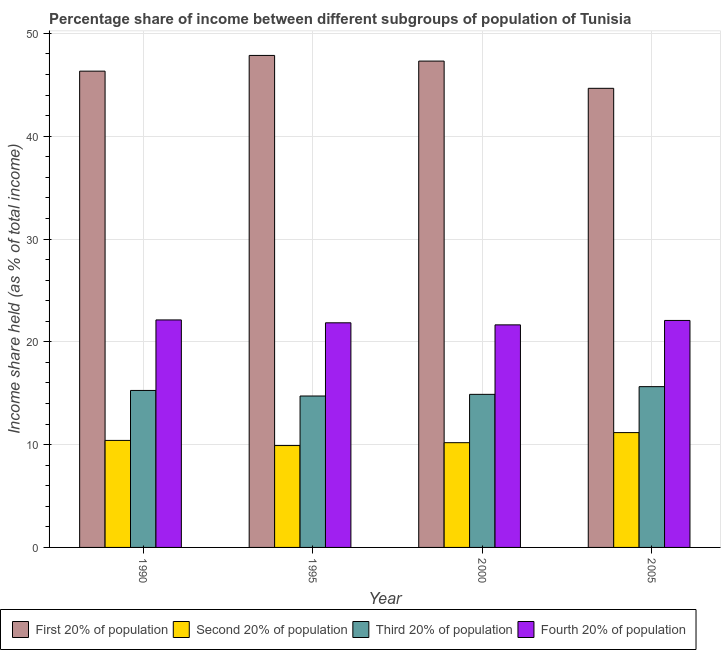How many groups of bars are there?
Offer a terse response. 4. Are the number of bars per tick equal to the number of legend labels?
Ensure brevity in your answer.  Yes. Are the number of bars on each tick of the X-axis equal?
Provide a succinct answer. Yes. What is the label of the 3rd group of bars from the left?
Your answer should be very brief. 2000. What is the share of the income held by fourth 20% of the population in 1990?
Ensure brevity in your answer.  22.13. Across all years, what is the maximum share of the income held by first 20% of the population?
Provide a short and direct response. 47.86. Across all years, what is the minimum share of the income held by third 20% of the population?
Provide a succinct answer. 14.73. What is the total share of the income held by fourth 20% of the population in the graph?
Keep it short and to the point. 87.71. What is the difference between the share of the income held by third 20% of the population in 1995 and that in 2005?
Give a very brief answer. -0.91. What is the difference between the share of the income held by first 20% of the population in 1995 and the share of the income held by second 20% of the population in 1990?
Your response must be concise. 1.53. What is the average share of the income held by third 20% of the population per year?
Make the answer very short. 15.13. In the year 1990, what is the difference between the share of the income held by second 20% of the population and share of the income held by first 20% of the population?
Your answer should be very brief. 0. What is the ratio of the share of the income held by second 20% of the population in 1990 to that in 2005?
Offer a terse response. 0.93. Is the difference between the share of the income held by fourth 20% of the population in 1990 and 1995 greater than the difference between the share of the income held by third 20% of the population in 1990 and 1995?
Ensure brevity in your answer.  No. What is the difference between the highest and the second highest share of the income held by fourth 20% of the population?
Make the answer very short. 0.05. What is the difference between the highest and the lowest share of the income held by second 20% of the population?
Offer a terse response. 1.26. Is it the case that in every year, the sum of the share of the income held by fourth 20% of the population and share of the income held by first 20% of the population is greater than the sum of share of the income held by third 20% of the population and share of the income held by second 20% of the population?
Give a very brief answer. No. What does the 4th bar from the left in 2000 represents?
Provide a short and direct response. Fourth 20% of population. What does the 4th bar from the right in 1995 represents?
Offer a terse response. First 20% of population. Is it the case that in every year, the sum of the share of the income held by first 20% of the population and share of the income held by second 20% of the population is greater than the share of the income held by third 20% of the population?
Give a very brief answer. Yes. How many bars are there?
Make the answer very short. 16. Are all the bars in the graph horizontal?
Provide a short and direct response. No. How many years are there in the graph?
Your response must be concise. 4. What is the difference between two consecutive major ticks on the Y-axis?
Your response must be concise. 10. How are the legend labels stacked?
Your answer should be very brief. Horizontal. What is the title of the graph?
Offer a very short reply. Percentage share of income between different subgroups of population of Tunisia. What is the label or title of the Y-axis?
Your answer should be compact. Income share held (as % of total income). What is the Income share held (as % of total income) of First 20% of population in 1990?
Offer a very short reply. 46.33. What is the Income share held (as % of total income) of Second 20% of population in 1990?
Provide a succinct answer. 10.41. What is the Income share held (as % of total income) in Third 20% of population in 1990?
Provide a succinct answer. 15.27. What is the Income share held (as % of total income) of Fourth 20% of population in 1990?
Your answer should be very brief. 22.13. What is the Income share held (as % of total income) of First 20% of population in 1995?
Offer a terse response. 47.86. What is the Income share held (as % of total income) of Second 20% of population in 1995?
Your answer should be very brief. 9.91. What is the Income share held (as % of total income) in Third 20% of population in 1995?
Provide a short and direct response. 14.73. What is the Income share held (as % of total income) of Fourth 20% of population in 1995?
Provide a succinct answer. 21.85. What is the Income share held (as % of total income) of First 20% of population in 2000?
Provide a short and direct response. 47.31. What is the Income share held (as % of total income) in Second 20% of population in 2000?
Your answer should be very brief. 10.19. What is the Income share held (as % of total income) of Third 20% of population in 2000?
Provide a succinct answer. 14.89. What is the Income share held (as % of total income) of Fourth 20% of population in 2000?
Provide a short and direct response. 21.65. What is the Income share held (as % of total income) of First 20% of population in 2005?
Provide a succinct answer. 44.66. What is the Income share held (as % of total income) in Second 20% of population in 2005?
Give a very brief answer. 11.17. What is the Income share held (as % of total income) of Third 20% of population in 2005?
Provide a succinct answer. 15.64. What is the Income share held (as % of total income) of Fourth 20% of population in 2005?
Offer a very short reply. 22.08. Across all years, what is the maximum Income share held (as % of total income) of First 20% of population?
Keep it short and to the point. 47.86. Across all years, what is the maximum Income share held (as % of total income) of Second 20% of population?
Your response must be concise. 11.17. Across all years, what is the maximum Income share held (as % of total income) of Third 20% of population?
Provide a short and direct response. 15.64. Across all years, what is the maximum Income share held (as % of total income) in Fourth 20% of population?
Your response must be concise. 22.13. Across all years, what is the minimum Income share held (as % of total income) in First 20% of population?
Provide a short and direct response. 44.66. Across all years, what is the minimum Income share held (as % of total income) in Second 20% of population?
Ensure brevity in your answer.  9.91. Across all years, what is the minimum Income share held (as % of total income) in Third 20% of population?
Provide a succinct answer. 14.73. Across all years, what is the minimum Income share held (as % of total income) in Fourth 20% of population?
Your response must be concise. 21.65. What is the total Income share held (as % of total income) in First 20% of population in the graph?
Keep it short and to the point. 186.16. What is the total Income share held (as % of total income) in Second 20% of population in the graph?
Provide a short and direct response. 41.68. What is the total Income share held (as % of total income) of Third 20% of population in the graph?
Give a very brief answer. 60.53. What is the total Income share held (as % of total income) in Fourth 20% of population in the graph?
Your response must be concise. 87.71. What is the difference between the Income share held (as % of total income) in First 20% of population in 1990 and that in 1995?
Your response must be concise. -1.53. What is the difference between the Income share held (as % of total income) of Third 20% of population in 1990 and that in 1995?
Offer a terse response. 0.54. What is the difference between the Income share held (as % of total income) in Fourth 20% of population in 1990 and that in 1995?
Your response must be concise. 0.28. What is the difference between the Income share held (as % of total income) of First 20% of population in 1990 and that in 2000?
Offer a terse response. -0.98. What is the difference between the Income share held (as % of total income) in Second 20% of population in 1990 and that in 2000?
Offer a very short reply. 0.22. What is the difference between the Income share held (as % of total income) in Third 20% of population in 1990 and that in 2000?
Keep it short and to the point. 0.38. What is the difference between the Income share held (as % of total income) in Fourth 20% of population in 1990 and that in 2000?
Your answer should be very brief. 0.48. What is the difference between the Income share held (as % of total income) in First 20% of population in 1990 and that in 2005?
Give a very brief answer. 1.67. What is the difference between the Income share held (as % of total income) of Second 20% of population in 1990 and that in 2005?
Provide a succinct answer. -0.76. What is the difference between the Income share held (as % of total income) in Third 20% of population in 1990 and that in 2005?
Give a very brief answer. -0.37. What is the difference between the Income share held (as % of total income) of First 20% of population in 1995 and that in 2000?
Provide a succinct answer. 0.55. What is the difference between the Income share held (as % of total income) in Second 20% of population in 1995 and that in 2000?
Give a very brief answer. -0.28. What is the difference between the Income share held (as % of total income) in Third 20% of population in 1995 and that in 2000?
Provide a succinct answer. -0.16. What is the difference between the Income share held (as % of total income) of Fourth 20% of population in 1995 and that in 2000?
Provide a short and direct response. 0.2. What is the difference between the Income share held (as % of total income) of First 20% of population in 1995 and that in 2005?
Offer a very short reply. 3.2. What is the difference between the Income share held (as % of total income) in Second 20% of population in 1995 and that in 2005?
Give a very brief answer. -1.26. What is the difference between the Income share held (as % of total income) in Third 20% of population in 1995 and that in 2005?
Ensure brevity in your answer.  -0.91. What is the difference between the Income share held (as % of total income) in Fourth 20% of population in 1995 and that in 2005?
Give a very brief answer. -0.23. What is the difference between the Income share held (as % of total income) in First 20% of population in 2000 and that in 2005?
Your answer should be compact. 2.65. What is the difference between the Income share held (as % of total income) of Second 20% of population in 2000 and that in 2005?
Provide a short and direct response. -0.98. What is the difference between the Income share held (as % of total income) of Third 20% of population in 2000 and that in 2005?
Give a very brief answer. -0.75. What is the difference between the Income share held (as % of total income) in Fourth 20% of population in 2000 and that in 2005?
Offer a terse response. -0.43. What is the difference between the Income share held (as % of total income) of First 20% of population in 1990 and the Income share held (as % of total income) of Second 20% of population in 1995?
Provide a short and direct response. 36.42. What is the difference between the Income share held (as % of total income) of First 20% of population in 1990 and the Income share held (as % of total income) of Third 20% of population in 1995?
Give a very brief answer. 31.6. What is the difference between the Income share held (as % of total income) in First 20% of population in 1990 and the Income share held (as % of total income) in Fourth 20% of population in 1995?
Offer a very short reply. 24.48. What is the difference between the Income share held (as % of total income) of Second 20% of population in 1990 and the Income share held (as % of total income) of Third 20% of population in 1995?
Make the answer very short. -4.32. What is the difference between the Income share held (as % of total income) in Second 20% of population in 1990 and the Income share held (as % of total income) in Fourth 20% of population in 1995?
Keep it short and to the point. -11.44. What is the difference between the Income share held (as % of total income) of Third 20% of population in 1990 and the Income share held (as % of total income) of Fourth 20% of population in 1995?
Offer a very short reply. -6.58. What is the difference between the Income share held (as % of total income) of First 20% of population in 1990 and the Income share held (as % of total income) of Second 20% of population in 2000?
Keep it short and to the point. 36.14. What is the difference between the Income share held (as % of total income) of First 20% of population in 1990 and the Income share held (as % of total income) of Third 20% of population in 2000?
Ensure brevity in your answer.  31.44. What is the difference between the Income share held (as % of total income) in First 20% of population in 1990 and the Income share held (as % of total income) in Fourth 20% of population in 2000?
Your answer should be very brief. 24.68. What is the difference between the Income share held (as % of total income) of Second 20% of population in 1990 and the Income share held (as % of total income) of Third 20% of population in 2000?
Offer a terse response. -4.48. What is the difference between the Income share held (as % of total income) of Second 20% of population in 1990 and the Income share held (as % of total income) of Fourth 20% of population in 2000?
Keep it short and to the point. -11.24. What is the difference between the Income share held (as % of total income) of Third 20% of population in 1990 and the Income share held (as % of total income) of Fourth 20% of population in 2000?
Give a very brief answer. -6.38. What is the difference between the Income share held (as % of total income) in First 20% of population in 1990 and the Income share held (as % of total income) in Second 20% of population in 2005?
Offer a very short reply. 35.16. What is the difference between the Income share held (as % of total income) in First 20% of population in 1990 and the Income share held (as % of total income) in Third 20% of population in 2005?
Your response must be concise. 30.69. What is the difference between the Income share held (as % of total income) in First 20% of population in 1990 and the Income share held (as % of total income) in Fourth 20% of population in 2005?
Provide a short and direct response. 24.25. What is the difference between the Income share held (as % of total income) in Second 20% of population in 1990 and the Income share held (as % of total income) in Third 20% of population in 2005?
Make the answer very short. -5.23. What is the difference between the Income share held (as % of total income) of Second 20% of population in 1990 and the Income share held (as % of total income) of Fourth 20% of population in 2005?
Keep it short and to the point. -11.67. What is the difference between the Income share held (as % of total income) in Third 20% of population in 1990 and the Income share held (as % of total income) in Fourth 20% of population in 2005?
Keep it short and to the point. -6.81. What is the difference between the Income share held (as % of total income) of First 20% of population in 1995 and the Income share held (as % of total income) of Second 20% of population in 2000?
Keep it short and to the point. 37.67. What is the difference between the Income share held (as % of total income) in First 20% of population in 1995 and the Income share held (as % of total income) in Third 20% of population in 2000?
Ensure brevity in your answer.  32.97. What is the difference between the Income share held (as % of total income) in First 20% of population in 1995 and the Income share held (as % of total income) in Fourth 20% of population in 2000?
Your answer should be very brief. 26.21. What is the difference between the Income share held (as % of total income) in Second 20% of population in 1995 and the Income share held (as % of total income) in Third 20% of population in 2000?
Ensure brevity in your answer.  -4.98. What is the difference between the Income share held (as % of total income) in Second 20% of population in 1995 and the Income share held (as % of total income) in Fourth 20% of population in 2000?
Make the answer very short. -11.74. What is the difference between the Income share held (as % of total income) of Third 20% of population in 1995 and the Income share held (as % of total income) of Fourth 20% of population in 2000?
Provide a short and direct response. -6.92. What is the difference between the Income share held (as % of total income) of First 20% of population in 1995 and the Income share held (as % of total income) of Second 20% of population in 2005?
Your response must be concise. 36.69. What is the difference between the Income share held (as % of total income) of First 20% of population in 1995 and the Income share held (as % of total income) of Third 20% of population in 2005?
Ensure brevity in your answer.  32.22. What is the difference between the Income share held (as % of total income) in First 20% of population in 1995 and the Income share held (as % of total income) in Fourth 20% of population in 2005?
Your answer should be very brief. 25.78. What is the difference between the Income share held (as % of total income) in Second 20% of population in 1995 and the Income share held (as % of total income) in Third 20% of population in 2005?
Ensure brevity in your answer.  -5.73. What is the difference between the Income share held (as % of total income) in Second 20% of population in 1995 and the Income share held (as % of total income) in Fourth 20% of population in 2005?
Your answer should be very brief. -12.17. What is the difference between the Income share held (as % of total income) of Third 20% of population in 1995 and the Income share held (as % of total income) of Fourth 20% of population in 2005?
Your answer should be very brief. -7.35. What is the difference between the Income share held (as % of total income) in First 20% of population in 2000 and the Income share held (as % of total income) in Second 20% of population in 2005?
Your response must be concise. 36.14. What is the difference between the Income share held (as % of total income) of First 20% of population in 2000 and the Income share held (as % of total income) of Third 20% of population in 2005?
Give a very brief answer. 31.67. What is the difference between the Income share held (as % of total income) of First 20% of population in 2000 and the Income share held (as % of total income) of Fourth 20% of population in 2005?
Ensure brevity in your answer.  25.23. What is the difference between the Income share held (as % of total income) of Second 20% of population in 2000 and the Income share held (as % of total income) of Third 20% of population in 2005?
Offer a very short reply. -5.45. What is the difference between the Income share held (as % of total income) in Second 20% of population in 2000 and the Income share held (as % of total income) in Fourth 20% of population in 2005?
Provide a succinct answer. -11.89. What is the difference between the Income share held (as % of total income) of Third 20% of population in 2000 and the Income share held (as % of total income) of Fourth 20% of population in 2005?
Offer a terse response. -7.19. What is the average Income share held (as % of total income) in First 20% of population per year?
Offer a very short reply. 46.54. What is the average Income share held (as % of total income) of Second 20% of population per year?
Keep it short and to the point. 10.42. What is the average Income share held (as % of total income) of Third 20% of population per year?
Ensure brevity in your answer.  15.13. What is the average Income share held (as % of total income) in Fourth 20% of population per year?
Provide a succinct answer. 21.93. In the year 1990, what is the difference between the Income share held (as % of total income) of First 20% of population and Income share held (as % of total income) of Second 20% of population?
Your response must be concise. 35.92. In the year 1990, what is the difference between the Income share held (as % of total income) in First 20% of population and Income share held (as % of total income) in Third 20% of population?
Your response must be concise. 31.06. In the year 1990, what is the difference between the Income share held (as % of total income) of First 20% of population and Income share held (as % of total income) of Fourth 20% of population?
Your answer should be compact. 24.2. In the year 1990, what is the difference between the Income share held (as % of total income) of Second 20% of population and Income share held (as % of total income) of Third 20% of population?
Offer a very short reply. -4.86. In the year 1990, what is the difference between the Income share held (as % of total income) of Second 20% of population and Income share held (as % of total income) of Fourth 20% of population?
Your answer should be very brief. -11.72. In the year 1990, what is the difference between the Income share held (as % of total income) in Third 20% of population and Income share held (as % of total income) in Fourth 20% of population?
Ensure brevity in your answer.  -6.86. In the year 1995, what is the difference between the Income share held (as % of total income) in First 20% of population and Income share held (as % of total income) in Second 20% of population?
Give a very brief answer. 37.95. In the year 1995, what is the difference between the Income share held (as % of total income) in First 20% of population and Income share held (as % of total income) in Third 20% of population?
Your answer should be very brief. 33.13. In the year 1995, what is the difference between the Income share held (as % of total income) in First 20% of population and Income share held (as % of total income) in Fourth 20% of population?
Keep it short and to the point. 26.01. In the year 1995, what is the difference between the Income share held (as % of total income) in Second 20% of population and Income share held (as % of total income) in Third 20% of population?
Give a very brief answer. -4.82. In the year 1995, what is the difference between the Income share held (as % of total income) in Second 20% of population and Income share held (as % of total income) in Fourth 20% of population?
Provide a succinct answer. -11.94. In the year 1995, what is the difference between the Income share held (as % of total income) of Third 20% of population and Income share held (as % of total income) of Fourth 20% of population?
Your answer should be compact. -7.12. In the year 2000, what is the difference between the Income share held (as % of total income) of First 20% of population and Income share held (as % of total income) of Second 20% of population?
Your answer should be very brief. 37.12. In the year 2000, what is the difference between the Income share held (as % of total income) in First 20% of population and Income share held (as % of total income) in Third 20% of population?
Offer a very short reply. 32.42. In the year 2000, what is the difference between the Income share held (as % of total income) of First 20% of population and Income share held (as % of total income) of Fourth 20% of population?
Provide a succinct answer. 25.66. In the year 2000, what is the difference between the Income share held (as % of total income) in Second 20% of population and Income share held (as % of total income) in Fourth 20% of population?
Offer a terse response. -11.46. In the year 2000, what is the difference between the Income share held (as % of total income) in Third 20% of population and Income share held (as % of total income) in Fourth 20% of population?
Offer a very short reply. -6.76. In the year 2005, what is the difference between the Income share held (as % of total income) of First 20% of population and Income share held (as % of total income) of Second 20% of population?
Ensure brevity in your answer.  33.49. In the year 2005, what is the difference between the Income share held (as % of total income) of First 20% of population and Income share held (as % of total income) of Third 20% of population?
Give a very brief answer. 29.02. In the year 2005, what is the difference between the Income share held (as % of total income) in First 20% of population and Income share held (as % of total income) in Fourth 20% of population?
Your response must be concise. 22.58. In the year 2005, what is the difference between the Income share held (as % of total income) in Second 20% of population and Income share held (as % of total income) in Third 20% of population?
Provide a succinct answer. -4.47. In the year 2005, what is the difference between the Income share held (as % of total income) of Second 20% of population and Income share held (as % of total income) of Fourth 20% of population?
Provide a short and direct response. -10.91. In the year 2005, what is the difference between the Income share held (as % of total income) of Third 20% of population and Income share held (as % of total income) of Fourth 20% of population?
Provide a short and direct response. -6.44. What is the ratio of the Income share held (as % of total income) in Second 20% of population in 1990 to that in 1995?
Provide a succinct answer. 1.05. What is the ratio of the Income share held (as % of total income) in Third 20% of population in 1990 to that in 1995?
Provide a short and direct response. 1.04. What is the ratio of the Income share held (as % of total income) in Fourth 20% of population in 1990 to that in 1995?
Your answer should be compact. 1.01. What is the ratio of the Income share held (as % of total income) of First 20% of population in 1990 to that in 2000?
Your answer should be very brief. 0.98. What is the ratio of the Income share held (as % of total income) of Second 20% of population in 1990 to that in 2000?
Offer a very short reply. 1.02. What is the ratio of the Income share held (as % of total income) of Third 20% of population in 1990 to that in 2000?
Ensure brevity in your answer.  1.03. What is the ratio of the Income share held (as % of total income) in Fourth 20% of population in 1990 to that in 2000?
Give a very brief answer. 1.02. What is the ratio of the Income share held (as % of total income) in First 20% of population in 1990 to that in 2005?
Your response must be concise. 1.04. What is the ratio of the Income share held (as % of total income) in Second 20% of population in 1990 to that in 2005?
Provide a succinct answer. 0.93. What is the ratio of the Income share held (as % of total income) in Third 20% of population in 1990 to that in 2005?
Make the answer very short. 0.98. What is the ratio of the Income share held (as % of total income) in First 20% of population in 1995 to that in 2000?
Make the answer very short. 1.01. What is the ratio of the Income share held (as % of total income) in Second 20% of population in 1995 to that in 2000?
Provide a short and direct response. 0.97. What is the ratio of the Income share held (as % of total income) of Third 20% of population in 1995 to that in 2000?
Provide a short and direct response. 0.99. What is the ratio of the Income share held (as % of total income) of Fourth 20% of population in 1995 to that in 2000?
Provide a short and direct response. 1.01. What is the ratio of the Income share held (as % of total income) of First 20% of population in 1995 to that in 2005?
Offer a very short reply. 1.07. What is the ratio of the Income share held (as % of total income) in Second 20% of population in 1995 to that in 2005?
Make the answer very short. 0.89. What is the ratio of the Income share held (as % of total income) of Third 20% of population in 1995 to that in 2005?
Your response must be concise. 0.94. What is the ratio of the Income share held (as % of total income) in Fourth 20% of population in 1995 to that in 2005?
Offer a very short reply. 0.99. What is the ratio of the Income share held (as % of total income) of First 20% of population in 2000 to that in 2005?
Your response must be concise. 1.06. What is the ratio of the Income share held (as % of total income) in Second 20% of population in 2000 to that in 2005?
Ensure brevity in your answer.  0.91. What is the ratio of the Income share held (as % of total income) of Third 20% of population in 2000 to that in 2005?
Provide a succinct answer. 0.95. What is the ratio of the Income share held (as % of total income) of Fourth 20% of population in 2000 to that in 2005?
Make the answer very short. 0.98. What is the difference between the highest and the second highest Income share held (as % of total income) in First 20% of population?
Offer a terse response. 0.55. What is the difference between the highest and the second highest Income share held (as % of total income) in Second 20% of population?
Your answer should be compact. 0.76. What is the difference between the highest and the second highest Income share held (as % of total income) of Third 20% of population?
Provide a short and direct response. 0.37. What is the difference between the highest and the second highest Income share held (as % of total income) of Fourth 20% of population?
Provide a short and direct response. 0.05. What is the difference between the highest and the lowest Income share held (as % of total income) of First 20% of population?
Ensure brevity in your answer.  3.2. What is the difference between the highest and the lowest Income share held (as % of total income) of Second 20% of population?
Keep it short and to the point. 1.26. What is the difference between the highest and the lowest Income share held (as % of total income) of Third 20% of population?
Make the answer very short. 0.91. What is the difference between the highest and the lowest Income share held (as % of total income) of Fourth 20% of population?
Offer a terse response. 0.48. 